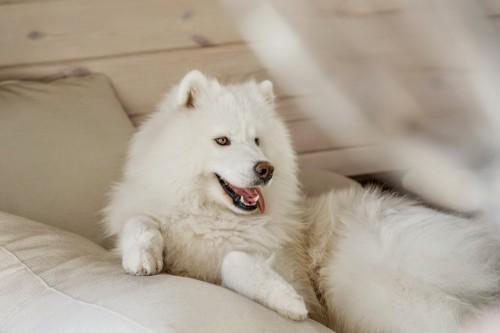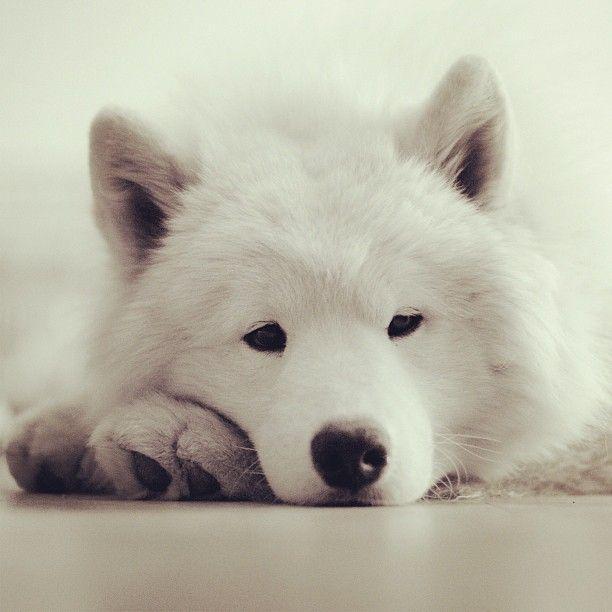The first image is the image on the left, the second image is the image on the right. Assess this claim about the two images: "All four dogs are white.". Correct or not? Answer yes or no. No. The first image is the image on the left, the second image is the image on the right. Considering the images on both sides, is "One image shows three same-sized white puppies posed side-by-side." valid? Answer yes or no. No. 